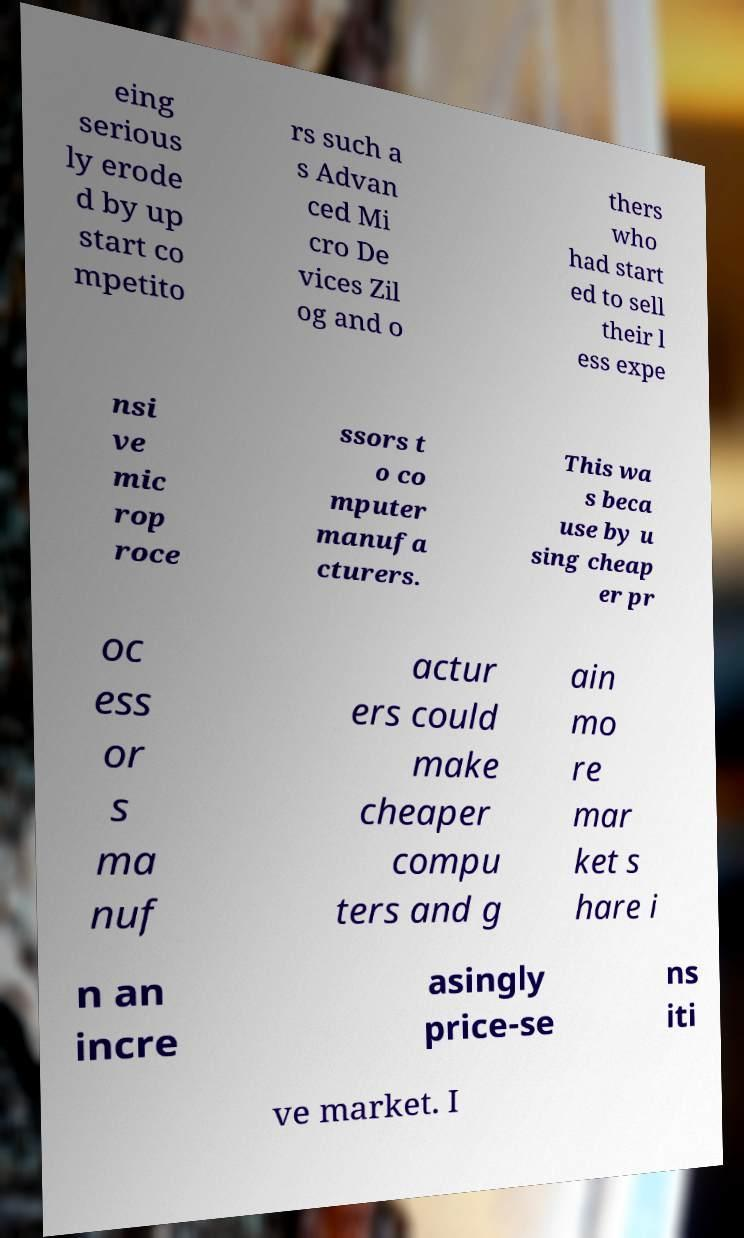Can you read and provide the text displayed in the image?This photo seems to have some interesting text. Can you extract and type it out for me? eing serious ly erode d by up start co mpetito rs such a s Advan ced Mi cro De vices Zil og and o thers who had start ed to sell their l ess expe nsi ve mic rop roce ssors t o co mputer manufa cturers. This wa s beca use by u sing cheap er pr oc ess or s ma nuf actur ers could make cheaper compu ters and g ain mo re mar ket s hare i n an incre asingly price-se ns iti ve market. I 